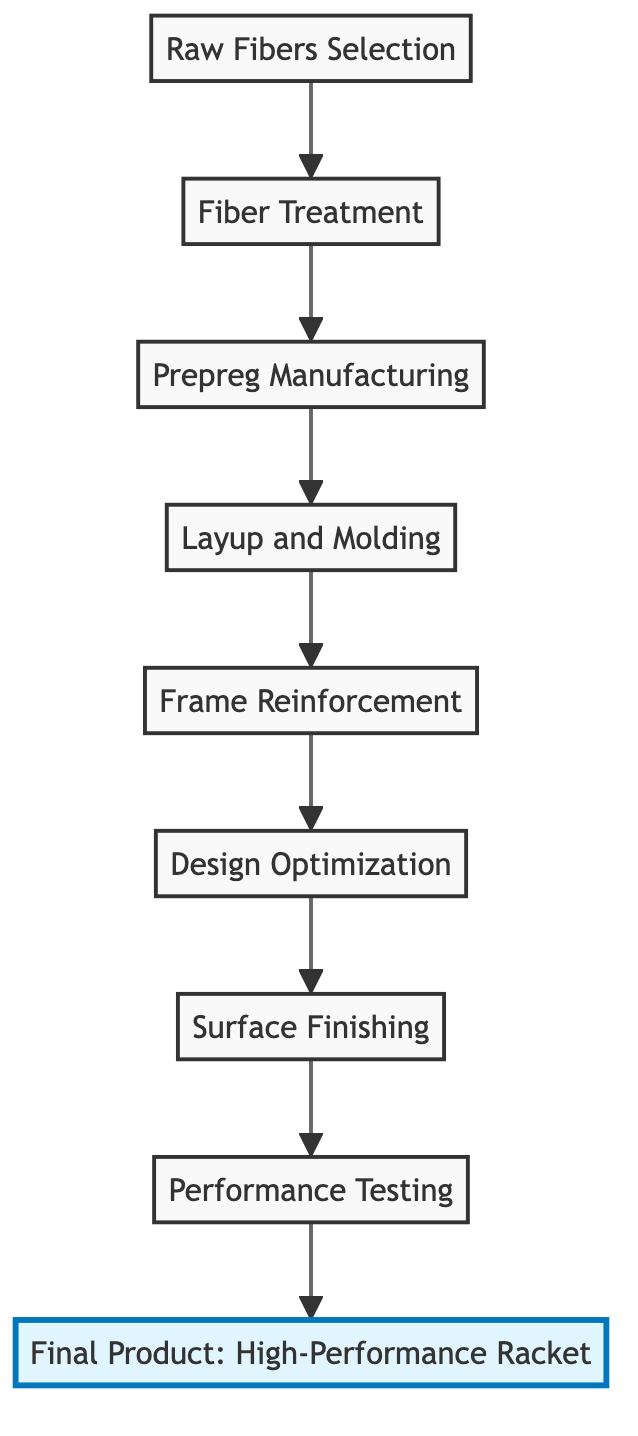What is the first stage in the flow chart? The flow chart starts with the first stage labeled "Raw Fibers Selection." This is the bottom node and initiates the process of developing composite materials for tennis rackets.
Answer: Raw Fibers Selection How many stages are shown in the diagram? Counting the nodes in the diagram reveals there are a total of 9 stages from "Raw Fibers Selection" to "Final Product: High-Performance Racket."
Answer: 9 What stage follows Fiber Treatment? From the diagram, the stage that follows "Fiber Treatment" is "Prepreg Manufacturing," which shows the progression in the process of creating tennis rackets.
Answer: Prepreg Manufacturing Which stage is directly before Performance Testing? The stage that comes directly before "Performance Testing" is "Surface Finishing," indicating the necessary steps leading up to the final performance evaluations of the racket.
Answer: Surface Finishing Which stages involve enhancing material properties? The stages that involve enhancing material properties are "Fiber Treatment" and "Frame Reinforcement." "Fiber Treatment" enhances fibers, and "Frame Reinforcement" optimizes the racket's structure.
Answer: Fiber Treatment, Frame Reinforcement What is the final product of this process? The last stage of the flow chart is "Final Product: High-Performance Racket," which indicates the end result of the entire composite materials evolution process.
Answer: Final Product: High-Performance Racket How many stages involve design optimization? There is one specific stage that focuses on the design aspects, which is "Design Optimization," indicating the use of engineering principles like CAD and FEA for refining design.
Answer: 1 What is the purpose of Prepreg Manufacturing? The purpose of "Prepreg Manufacturing" is to impregnate fibers with resin matrices, which is a crucial step in creating the structural components of the racket.
Answer: Impregnating fibers with resin matrices What techniques are mentioned in the Layup and Molding stage? "Layup and Molding" involves techniques like autoclaving and compression molding, which are essential for shaping and forming the racket frame from the prepreg sheets.
Answer: Autoclaving, compression molding 